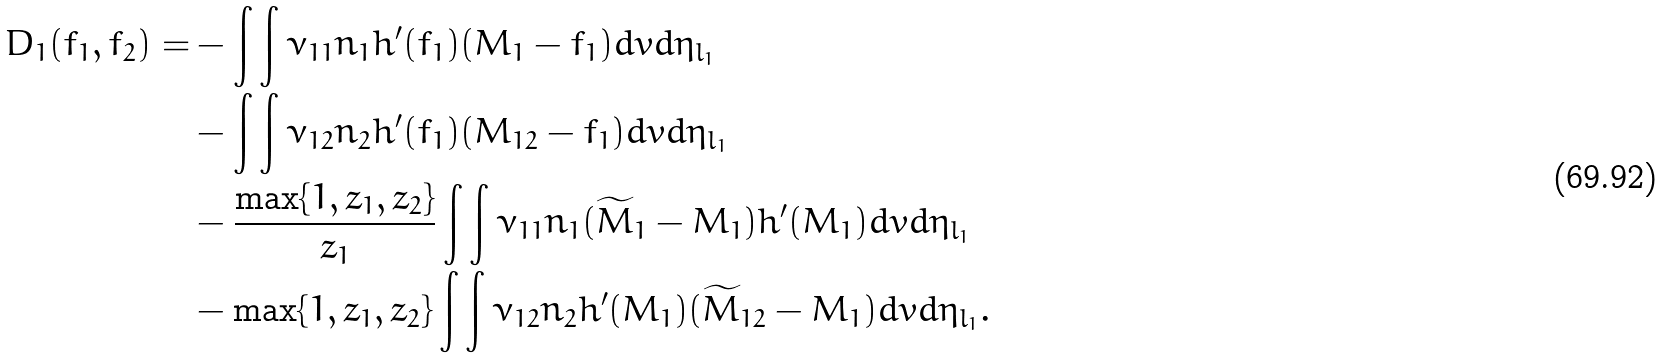<formula> <loc_0><loc_0><loc_500><loc_500>D _ { 1 } ( f _ { 1 } , f _ { 2 } ) = & - \int \int \nu _ { 1 1 } n _ { 1 } h ^ { \prime } ( f _ { 1 } ) ( M _ { 1 } - f _ { 1 } ) d v d \eta _ { l _ { 1 } } \\ & - \int \int \nu _ { 1 2 } n _ { 2 } h ^ { \prime } ( f _ { 1 } ) ( M _ { 1 2 } - f _ { 1 } ) d v d \eta _ { l _ { 1 } } \\ & - \frac { \max \{ 1 , z _ { 1 } , z _ { 2 } \} } { z _ { 1 } } \int \int \nu _ { 1 1 } n _ { 1 } ( \widetilde { M } _ { 1 } - M _ { 1 } ) h ^ { \prime } ( M _ { 1 } ) d v d \eta _ { l _ { 1 } } \\ & - \max \{ 1 , z _ { 1 } , z _ { 2 } \} \int \int \nu _ { 1 2 } n _ { 2 } h ^ { \prime } ( M _ { 1 } ) ( \widetilde { M } _ { 1 2 } - M _ { 1 } ) d v d \eta _ { l _ { 1 } } .</formula> 